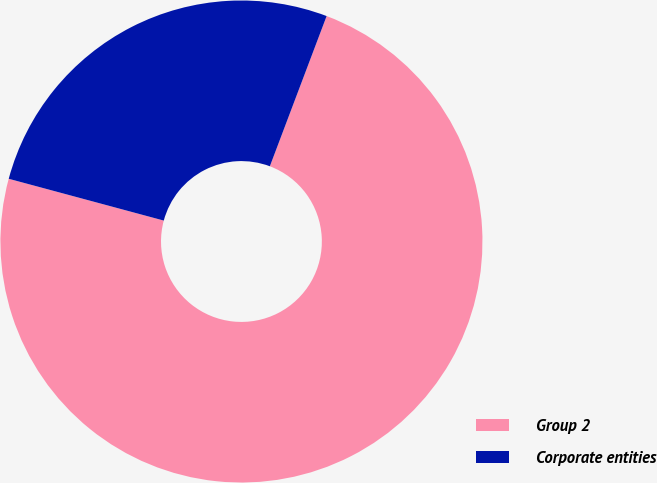<chart> <loc_0><loc_0><loc_500><loc_500><pie_chart><fcel>Group 2<fcel>Corporate entities<nl><fcel>73.44%<fcel>26.56%<nl></chart> 